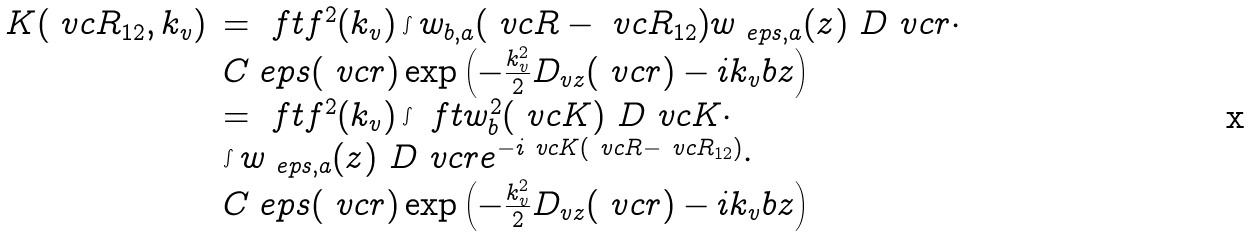Convert formula to latex. <formula><loc_0><loc_0><loc_500><loc_500>\begin{array} { l l } K ( \ v c { R } _ { 1 2 } , k _ { v } ) & = \ f t { f } ^ { 2 } ( k _ { v } ) \int w _ { b , a } ( \ v c { R } - \ v c { R } _ { 1 2 } ) w _ { \ e p s , a } ( z ) \ D { \ v c { r } } \cdot \\ & C _ { \ } e p s ( \ v c { r } ) \exp \left ( - \frac { k _ { v } ^ { 2 } } { 2 } D _ { v z } ( \ v c { r } ) - i k _ { v } b z \right ) \\ & = \ f t { f } ^ { 2 } ( k _ { v } ) \int \ f t { w } _ { b } ^ { 2 } ( \ v c { K } ) \ D { \ v c { K } } \cdot \\ & \int w _ { \ e p s , a } ( z ) \ D { \ v c { r } } e ^ { - i \ v c { K } ( \ v c { R } - \ v c { R } _ { 1 2 } ) } \cdot \\ & C _ { \ } e p s ( \ v c { r } ) \exp \left ( - \frac { k _ { v } ^ { 2 } } { 2 } D _ { v z } ( \ v c { r } ) - i k _ { v } b z \right ) \end{array}</formula> 